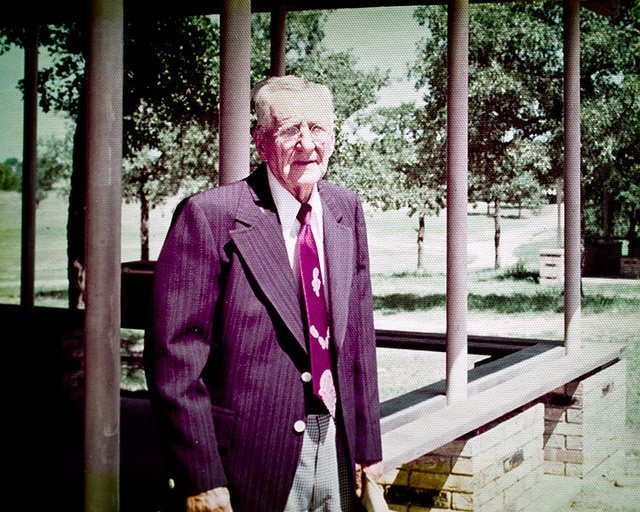Describe the objects in this image and their specific colors. I can see people in black, purple, and lightgray tones and tie in black, purple, and lavender tones in this image. 